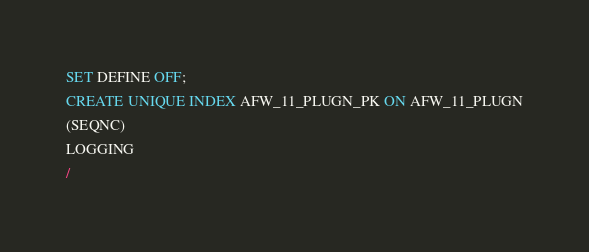<code> <loc_0><loc_0><loc_500><loc_500><_SQL_>SET DEFINE OFF;
CREATE UNIQUE INDEX AFW_11_PLUGN_PK ON AFW_11_PLUGN
(SEQNC)
LOGGING
/
</code> 